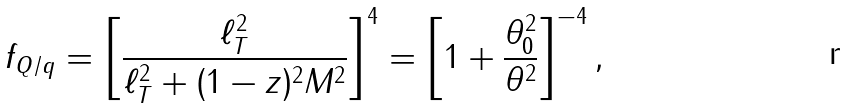Convert formula to latex. <formula><loc_0><loc_0><loc_500><loc_500>f _ { Q / q } = \left [ \frac { \ell _ { T } ^ { 2 } } { \ell _ { T } ^ { 2 } + ( 1 - z ) ^ { 2 } M ^ { 2 } } \right ] ^ { 4 } = \left [ 1 + \frac { \theta _ { 0 } ^ { 2 } } { \theta ^ { 2 } } \right ] ^ { - 4 } ,</formula> 